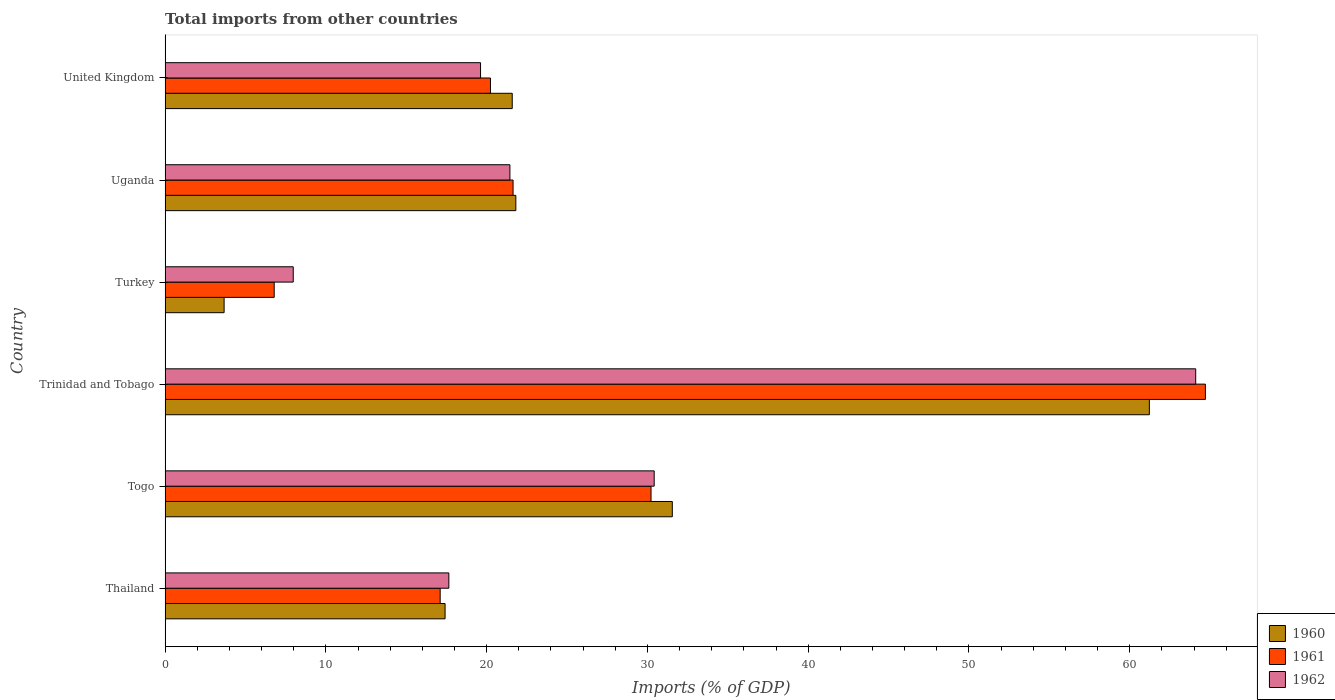How many different coloured bars are there?
Your answer should be compact. 3. How many groups of bars are there?
Ensure brevity in your answer.  6. Are the number of bars per tick equal to the number of legend labels?
Your answer should be compact. Yes. How many bars are there on the 4th tick from the top?
Give a very brief answer. 3. How many bars are there on the 6th tick from the bottom?
Keep it short and to the point. 3. What is the label of the 4th group of bars from the top?
Ensure brevity in your answer.  Trinidad and Tobago. What is the total imports in 1962 in Uganda?
Provide a short and direct response. 21.45. Across all countries, what is the maximum total imports in 1961?
Give a very brief answer. 64.71. Across all countries, what is the minimum total imports in 1962?
Your response must be concise. 7.97. In which country was the total imports in 1962 maximum?
Ensure brevity in your answer.  Trinidad and Tobago. What is the total total imports in 1961 in the graph?
Ensure brevity in your answer.  160.72. What is the difference between the total imports in 1960 in Trinidad and Tobago and that in Uganda?
Provide a succinct answer. 39.41. What is the difference between the total imports in 1960 in Thailand and the total imports in 1961 in Togo?
Your answer should be compact. -12.81. What is the average total imports in 1961 per country?
Your response must be concise. 26.79. What is the difference between the total imports in 1961 and total imports in 1962 in Thailand?
Offer a very short reply. -0.54. In how many countries, is the total imports in 1960 greater than 62 %?
Your answer should be compact. 0. What is the ratio of the total imports in 1961 in Turkey to that in Uganda?
Offer a very short reply. 0.31. Is the difference between the total imports in 1961 in Uganda and United Kingdom greater than the difference between the total imports in 1962 in Uganda and United Kingdom?
Give a very brief answer. No. What is the difference between the highest and the second highest total imports in 1960?
Make the answer very short. 29.67. What is the difference between the highest and the lowest total imports in 1960?
Your answer should be very brief. 57.55. What does the 1st bar from the top in Thailand represents?
Give a very brief answer. 1962. Is it the case that in every country, the sum of the total imports in 1961 and total imports in 1962 is greater than the total imports in 1960?
Your answer should be very brief. Yes. Are all the bars in the graph horizontal?
Keep it short and to the point. Yes. Are the values on the major ticks of X-axis written in scientific E-notation?
Your answer should be compact. No. Does the graph contain any zero values?
Offer a very short reply. No. Where does the legend appear in the graph?
Provide a succinct answer. Bottom right. What is the title of the graph?
Give a very brief answer. Total imports from other countries. Does "1987" appear as one of the legend labels in the graph?
Provide a succinct answer. No. What is the label or title of the X-axis?
Provide a succinct answer. Imports (% of GDP). What is the label or title of the Y-axis?
Your answer should be compact. Country. What is the Imports (% of GDP) in 1960 in Thailand?
Offer a terse response. 17.42. What is the Imports (% of GDP) in 1961 in Thailand?
Give a very brief answer. 17.11. What is the Imports (% of GDP) of 1962 in Thailand?
Your answer should be compact. 17.65. What is the Imports (% of GDP) in 1960 in Togo?
Offer a terse response. 31.55. What is the Imports (% of GDP) in 1961 in Togo?
Make the answer very short. 30.23. What is the Imports (% of GDP) in 1962 in Togo?
Offer a terse response. 30.42. What is the Imports (% of GDP) of 1960 in Trinidad and Tobago?
Your answer should be compact. 61.22. What is the Imports (% of GDP) in 1961 in Trinidad and Tobago?
Ensure brevity in your answer.  64.71. What is the Imports (% of GDP) of 1962 in Trinidad and Tobago?
Your response must be concise. 64.1. What is the Imports (% of GDP) in 1960 in Turkey?
Keep it short and to the point. 3.67. What is the Imports (% of GDP) in 1961 in Turkey?
Your answer should be very brief. 6.79. What is the Imports (% of GDP) of 1962 in Turkey?
Offer a terse response. 7.97. What is the Imports (% of GDP) in 1960 in Uganda?
Offer a terse response. 21.82. What is the Imports (% of GDP) in 1961 in Uganda?
Make the answer very short. 21.64. What is the Imports (% of GDP) of 1962 in Uganda?
Give a very brief answer. 21.45. What is the Imports (% of GDP) in 1960 in United Kingdom?
Your answer should be compact. 21.59. What is the Imports (% of GDP) of 1961 in United Kingdom?
Make the answer very short. 20.24. What is the Imports (% of GDP) in 1962 in United Kingdom?
Provide a short and direct response. 19.62. Across all countries, what is the maximum Imports (% of GDP) of 1960?
Provide a succinct answer. 61.22. Across all countries, what is the maximum Imports (% of GDP) in 1961?
Your response must be concise. 64.71. Across all countries, what is the maximum Imports (% of GDP) in 1962?
Your answer should be compact. 64.1. Across all countries, what is the minimum Imports (% of GDP) of 1960?
Your response must be concise. 3.67. Across all countries, what is the minimum Imports (% of GDP) in 1961?
Give a very brief answer. 6.79. Across all countries, what is the minimum Imports (% of GDP) of 1962?
Keep it short and to the point. 7.97. What is the total Imports (% of GDP) of 1960 in the graph?
Ensure brevity in your answer.  157.27. What is the total Imports (% of GDP) in 1961 in the graph?
Keep it short and to the point. 160.72. What is the total Imports (% of GDP) in 1962 in the graph?
Keep it short and to the point. 161.22. What is the difference between the Imports (% of GDP) in 1960 in Thailand and that in Togo?
Your answer should be compact. -14.13. What is the difference between the Imports (% of GDP) of 1961 in Thailand and that in Togo?
Provide a short and direct response. -13.12. What is the difference between the Imports (% of GDP) of 1962 in Thailand and that in Togo?
Make the answer very short. -12.77. What is the difference between the Imports (% of GDP) of 1960 in Thailand and that in Trinidad and Tobago?
Give a very brief answer. -43.81. What is the difference between the Imports (% of GDP) in 1961 in Thailand and that in Trinidad and Tobago?
Make the answer very short. -47.6. What is the difference between the Imports (% of GDP) in 1962 in Thailand and that in Trinidad and Tobago?
Make the answer very short. -46.46. What is the difference between the Imports (% of GDP) of 1960 in Thailand and that in Turkey?
Your response must be concise. 13.74. What is the difference between the Imports (% of GDP) in 1961 in Thailand and that in Turkey?
Offer a terse response. 10.32. What is the difference between the Imports (% of GDP) of 1962 in Thailand and that in Turkey?
Offer a very short reply. 9.68. What is the difference between the Imports (% of GDP) of 1960 in Thailand and that in Uganda?
Give a very brief answer. -4.4. What is the difference between the Imports (% of GDP) of 1961 in Thailand and that in Uganda?
Your answer should be very brief. -4.53. What is the difference between the Imports (% of GDP) in 1962 in Thailand and that in Uganda?
Your response must be concise. -3.8. What is the difference between the Imports (% of GDP) of 1960 in Thailand and that in United Kingdom?
Keep it short and to the point. -4.18. What is the difference between the Imports (% of GDP) in 1961 in Thailand and that in United Kingdom?
Your answer should be very brief. -3.13. What is the difference between the Imports (% of GDP) in 1962 in Thailand and that in United Kingdom?
Provide a succinct answer. -1.97. What is the difference between the Imports (% of GDP) of 1960 in Togo and that in Trinidad and Tobago?
Give a very brief answer. -29.67. What is the difference between the Imports (% of GDP) of 1961 in Togo and that in Trinidad and Tobago?
Keep it short and to the point. -34.48. What is the difference between the Imports (% of GDP) of 1962 in Togo and that in Trinidad and Tobago?
Make the answer very short. -33.68. What is the difference between the Imports (% of GDP) of 1960 in Togo and that in Turkey?
Your answer should be compact. 27.88. What is the difference between the Imports (% of GDP) in 1961 in Togo and that in Turkey?
Your answer should be very brief. 23.44. What is the difference between the Imports (% of GDP) in 1962 in Togo and that in Turkey?
Your answer should be compact. 22.45. What is the difference between the Imports (% of GDP) of 1960 in Togo and that in Uganda?
Give a very brief answer. 9.73. What is the difference between the Imports (% of GDP) in 1961 in Togo and that in Uganda?
Provide a succinct answer. 8.58. What is the difference between the Imports (% of GDP) in 1962 in Togo and that in Uganda?
Your response must be concise. 8.97. What is the difference between the Imports (% of GDP) in 1960 in Togo and that in United Kingdom?
Your answer should be compact. 9.96. What is the difference between the Imports (% of GDP) in 1961 in Togo and that in United Kingdom?
Your response must be concise. 9.99. What is the difference between the Imports (% of GDP) of 1962 in Togo and that in United Kingdom?
Your answer should be compact. 10.8. What is the difference between the Imports (% of GDP) of 1960 in Trinidad and Tobago and that in Turkey?
Provide a succinct answer. 57.55. What is the difference between the Imports (% of GDP) in 1961 in Trinidad and Tobago and that in Turkey?
Your response must be concise. 57.92. What is the difference between the Imports (% of GDP) of 1962 in Trinidad and Tobago and that in Turkey?
Your response must be concise. 56.13. What is the difference between the Imports (% of GDP) in 1960 in Trinidad and Tobago and that in Uganda?
Provide a succinct answer. 39.41. What is the difference between the Imports (% of GDP) of 1961 in Trinidad and Tobago and that in Uganda?
Your answer should be very brief. 43.06. What is the difference between the Imports (% of GDP) of 1962 in Trinidad and Tobago and that in Uganda?
Your answer should be compact. 42.66. What is the difference between the Imports (% of GDP) in 1960 in Trinidad and Tobago and that in United Kingdom?
Your response must be concise. 39.63. What is the difference between the Imports (% of GDP) of 1961 in Trinidad and Tobago and that in United Kingdom?
Your response must be concise. 44.47. What is the difference between the Imports (% of GDP) in 1962 in Trinidad and Tobago and that in United Kingdom?
Make the answer very short. 44.48. What is the difference between the Imports (% of GDP) in 1960 in Turkey and that in Uganda?
Offer a terse response. -18.15. What is the difference between the Imports (% of GDP) in 1961 in Turkey and that in Uganda?
Make the answer very short. -14.86. What is the difference between the Imports (% of GDP) in 1962 in Turkey and that in Uganda?
Offer a very short reply. -13.48. What is the difference between the Imports (% of GDP) of 1960 in Turkey and that in United Kingdom?
Your answer should be compact. -17.92. What is the difference between the Imports (% of GDP) in 1961 in Turkey and that in United Kingdom?
Give a very brief answer. -13.45. What is the difference between the Imports (% of GDP) in 1962 in Turkey and that in United Kingdom?
Make the answer very short. -11.65. What is the difference between the Imports (% of GDP) of 1960 in Uganda and that in United Kingdom?
Provide a succinct answer. 0.22. What is the difference between the Imports (% of GDP) in 1961 in Uganda and that in United Kingdom?
Ensure brevity in your answer.  1.4. What is the difference between the Imports (% of GDP) in 1962 in Uganda and that in United Kingdom?
Make the answer very short. 1.83. What is the difference between the Imports (% of GDP) in 1960 in Thailand and the Imports (% of GDP) in 1961 in Togo?
Make the answer very short. -12.81. What is the difference between the Imports (% of GDP) of 1960 in Thailand and the Imports (% of GDP) of 1962 in Togo?
Make the answer very short. -13.01. What is the difference between the Imports (% of GDP) in 1961 in Thailand and the Imports (% of GDP) in 1962 in Togo?
Provide a succinct answer. -13.31. What is the difference between the Imports (% of GDP) in 1960 in Thailand and the Imports (% of GDP) in 1961 in Trinidad and Tobago?
Ensure brevity in your answer.  -47.29. What is the difference between the Imports (% of GDP) in 1960 in Thailand and the Imports (% of GDP) in 1962 in Trinidad and Tobago?
Ensure brevity in your answer.  -46.69. What is the difference between the Imports (% of GDP) of 1961 in Thailand and the Imports (% of GDP) of 1962 in Trinidad and Tobago?
Your answer should be compact. -46.99. What is the difference between the Imports (% of GDP) in 1960 in Thailand and the Imports (% of GDP) in 1961 in Turkey?
Ensure brevity in your answer.  10.63. What is the difference between the Imports (% of GDP) in 1960 in Thailand and the Imports (% of GDP) in 1962 in Turkey?
Ensure brevity in your answer.  9.45. What is the difference between the Imports (% of GDP) in 1961 in Thailand and the Imports (% of GDP) in 1962 in Turkey?
Ensure brevity in your answer.  9.14. What is the difference between the Imports (% of GDP) in 1960 in Thailand and the Imports (% of GDP) in 1961 in Uganda?
Your answer should be compact. -4.23. What is the difference between the Imports (% of GDP) in 1960 in Thailand and the Imports (% of GDP) in 1962 in Uganda?
Keep it short and to the point. -4.03. What is the difference between the Imports (% of GDP) in 1961 in Thailand and the Imports (% of GDP) in 1962 in Uganda?
Ensure brevity in your answer.  -4.34. What is the difference between the Imports (% of GDP) in 1960 in Thailand and the Imports (% of GDP) in 1961 in United Kingdom?
Provide a short and direct response. -2.82. What is the difference between the Imports (% of GDP) in 1960 in Thailand and the Imports (% of GDP) in 1962 in United Kingdom?
Your answer should be very brief. -2.21. What is the difference between the Imports (% of GDP) of 1961 in Thailand and the Imports (% of GDP) of 1962 in United Kingdom?
Your response must be concise. -2.51. What is the difference between the Imports (% of GDP) of 1960 in Togo and the Imports (% of GDP) of 1961 in Trinidad and Tobago?
Provide a short and direct response. -33.16. What is the difference between the Imports (% of GDP) in 1960 in Togo and the Imports (% of GDP) in 1962 in Trinidad and Tobago?
Offer a very short reply. -32.56. What is the difference between the Imports (% of GDP) in 1961 in Togo and the Imports (% of GDP) in 1962 in Trinidad and Tobago?
Provide a succinct answer. -33.88. What is the difference between the Imports (% of GDP) of 1960 in Togo and the Imports (% of GDP) of 1961 in Turkey?
Ensure brevity in your answer.  24.76. What is the difference between the Imports (% of GDP) of 1960 in Togo and the Imports (% of GDP) of 1962 in Turkey?
Offer a very short reply. 23.58. What is the difference between the Imports (% of GDP) of 1961 in Togo and the Imports (% of GDP) of 1962 in Turkey?
Provide a succinct answer. 22.26. What is the difference between the Imports (% of GDP) of 1960 in Togo and the Imports (% of GDP) of 1961 in Uganda?
Provide a short and direct response. 9.91. What is the difference between the Imports (% of GDP) in 1960 in Togo and the Imports (% of GDP) in 1962 in Uganda?
Your response must be concise. 10.1. What is the difference between the Imports (% of GDP) of 1961 in Togo and the Imports (% of GDP) of 1962 in Uganda?
Provide a short and direct response. 8.78. What is the difference between the Imports (% of GDP) of 1960 in Togo and the Imports (% of GDP) of 1961 in United Kingdom?
Your answer should be compact. 11.31. What is the difference between the Imports (% of GDP) of 1960 in Togo and the Imports (% of GDP) of 1962 in United Kingdom?
Give a very brief answer. 11.93. What is the difference between the Imports (% of GDP) of 1961 in Togo and the Imports (% of GDP) of 1962 in United Kingdom?
Ensure brevity in your answer.  10.6. What is the difference between the Imports (% of GDP) in 1960 in Trinidad and Tobago and the Imports (% of GDP) in 1961 in Turkey?
Provide a short and direct response. 54.44. What is the difference between the Imports (% of GDP) of 1960 in Trinidad and Tobago and the Imports (% of GDP) of 1962 in Turkey?
Keep it short and to the point. 53.25. What is the difference between the Imports (% of GDP) in 1961 in Trinidad and Tobago and the Imports (% of GDP) in 1962 in Turkey?
Provide a short and direct response. 56.74. What is the difference between the Imports (% of GDP) of 1960 in Trinidad and Tobago and the Imports (% of GDP) of 1961 in Uganda?
Ensure brevity in your answer.  39.58. What is the difference between the Imports (% of GDP) in 1960 in Trinidad and Tobago and the Imports (% of GDP) in 1962 in Uganda?
Ensure brevity in your answer.  39.77. What is the difference between the Imports (% of GDP) in 1961 in Trinidad and Tobago and the Imports (% of GDP) in 1962 in Uganda?
Your response must be concise. 43.26. What is the difference between the Imports (% of GDP) of 1960 in Trinidad and Tobago and the Imports (% of GDP) of 1961 in United Kingdom?
Your response must be concise. 40.98. What is the difference between the Imports (% of GDP) of 1960 in Trinidad and Tobago and the Imports (% of GDP) of 1962 in United Kingdom?
Provide a succinct answer. 41.6. What is the difference between the Imports (% of GDP) in 1961 in Trinidad and Tobago and the Imports (% of GDP) in 1962 in United Kingdom?
Give a very brief answer. 45.09. What is the difference between the Imports (% of GDP) of 1960 in Turkey and the Imports (% of GDP) of 1961 in Uganda?
Offer a terse response. -17.97. What is the difference between the Imports (% of GDP) of 1960 in Turkey and the Imports (% of GDP) of 1962 in Uganda?
Make the answer very short. -17.78. What is the difference between the Imports (% of GDP) of 1961 in Turkey and the Imports (% of GDP) of 1962 in Uganda?
Offer a terse response. -14.66. What is the difference between the Imports (% of GDP) in 1960 in Turkey and the Imports (% of GDP) in 1961 in United Kingdom?
Offer a terse response. -16.57. What is the difference between the Imports (% of GDP) of 1960 in Turkey and the Imports (% of GDP) of 1962 in United Kingdom?
Make the answer very short. -15.95. What is the difference between the Imports (% of GDP) of 1961 in Turkey and the Imports (% of GDP) of 1962 in United Kingdom?
Keep it short and to the point. -12.83. What is the difference between the Imports (% of GDP) in 1960 in Uganda and the Imports (% of GDP) in 1961 in United Kingdom?
Your answer should be very brief. 1.58. What is the difference between the Imports (% of GDP) in 1960 in Uganda and the Imports (% of GDP) in 1962 in United Kingdom?
Make the answer very short. 2.2. What is the difference between the Imports (% of GDP) of 1961 in Uganda and the Imports (% of GDP) of 1962 in United Kingdom?
Ensure brevity in your answer.  2.02. What is the average Imports (% of GDP) of 1960 per country?
Keep it short and to the point. 26.21. What is the average Imports (% of GDP) of 1961 per country?
Keep it short and to the point. 26.79. What is the average Imports (% of GDP) of 1962 per country?
Your response must be concise. 26.87. What is the difference between the Imports (% of GDP) of 1960 and Imports (% of GDP) of 1961 in Thailand?
Keep it short and to the point. 0.31. What is the difference between the Imports (% of GDP) of 1960 and Imports (% of GDP) of 1962 in Thailand?
Keep it short and to the point. -0.23. What is the difference between the Imports (% of GDP) in 1961 and Imports (% of GDP) in 1962 in Thailand?
Offer a terse response. -0.54. What is the difference between the Imports (% of GDP) of 1960 and Imports (% of GDP) of 1961 in Togo?
Offer a terse response. 1.32. What is the difference between the Imports (% of GDP) in 1960 and Imports (% of GDP) in 1962 in Togo?
Keep it short and to the point. 1.13. What is the difference between the Imports (% of GDP) of 1961 and Imports (% of GDP) of 1962 in Togo?
Offer a very short reply. -0.2. What is the difference between the Imports (% of GDP) in 1960 and Imports (% of GDP) in 1961 in Trinidad and Tobago?
Give a very brief answer. -3.49. What is the difference between the Imports (% of GDP) in 1960 and Imports (% of GDP) in 1962 in Trinidad and Tobago?
Make the answer very short. -2.88. What is the difference between the Imports (% of GDP) in 1961 and Imports (% of GDP) in 1962 in Trinidad and Tobago?
Ensure brevity in your answer.  0.6. What is the difference between the Imports (% of GDP) of 1960 and Imports (% of GDP) of 1961 in Turkey?
Your answer should be compact. -3.12. What is the difference between the Imports (% of GDP) of 1960 and Imports (% of GDP) of 1962 in Turkey?
Provide a short and direct response. -4.3. What is the difference between the Imports (% of GDP) in 1961 and Imports (% of GDP) in 1962 in Turkey?
Give a very brief answer. -1.18. What is the difference between the Imports (% of GDP) in 1960 and Imports (% of GDP) in 1961 in Uganda?
Ensure brevity in your answer.  0.17. What is the difference between the Imports (% of GDP) in 1960 and Imports (% of GDP) in 1962 in Uganda?
Your answer should be very brief. 0.37. What is the difference between the Imports (% of GDP) in 1961 and Imports (% of GDP) in 1962 in Uganda?
Make the answer very short. 0.2. What is the difference between the Imports (% of GDP) of 1960 and Imports (% of GDP) of 1961 in United Kingdom?
Ensure brevity in your answer.  1.35. What is the difference between the Imports (% of GDP) of 1960 and Imports (% of GDP) of 1962 in United Kingdom?
Ensure brevity in your answer.  1.97. What is the difference between the Imports (% of GDP) in 1961 and Imports (% of GDP) in 1962 in United Kingdom?
Ensure brevity in your answer.  0.62. What is the ratio of the Imports (% of GDP) of 1960 in Thailand to that in Togo?
Ensure brevity in your answer.  0.55. What is the ratio of the Imports (% of GDP) in 1961 in Thailand to that in Togo?
Ensure brevity in your answer.  0.57. What is the ratio of the Imports (% of GDP) of 1962 in Thailand to that in Togo?
Offer a terse response. 0.58. What is the ratio of the Imports (% of GDP) of 1960 in Thailand to that in Trinidad and Tobago?
Give a very brief answer. 0.28. What is the ratio of the Imports (% of GDP) in 1961 in Thailand to that in Trinidad and Tobago?
Keep it short and to the point. 0.26. What is the ratio of the Imports (% of GDP) in 1962 in Thailand to that in Trinidad and Tobago?
Provide a short and direct response. 0.28. What is the ratio of the Imports (% of GDP) of 1960 in Thailand to that in Turkey?
Your answer should be very brief. 4.74. What is the ratio of the Imports (% of GDP) of 1961 in Thailand to that in Turkey?
Ensure brevity in your answer.  2.52. What is the ratio of the Imports (% of GDP) in 1962 in Thailand to that in Turkey?
Make the answer very short. 2.21. What is the ratio of the Imports (% of GDP) in 1960 in Thailand to that in Uganda?
Offer a terse response. 0.8. What is the ratio of the Imports (% of GDP) of 1961 in Thailand to that in Uganda?
Offer a terse response. 0.79. What is the ratio of the Imports (% of GDP) in 1962 in Thailand to that in Uganda?
Keep it short and to the point. 0.82. What is the ratio of the Imports (% of GDP) in 1960 in Thailand to that in United Kingdom?
Offer a terse response. 0.81. What is the ratio of the Imports (% of GDP) in 1961 in Thailand to that in United Kingdom?
Your answer should be compact. 0.85. What is the ratio of the Imports (% of GDP) in 1962 in Thailand to that in United Kingdom?
Keep it short and to the point. 0.9. What is the ratio of the Imports (% of GDP) of 1960 in Togo to that in Trinidad and Tobago?
Your response must be concise. 0.52. What is the ratio of the Imports (% of GDP) in 1961 in Togo to that in Trinidad and Tobago?
Offer a terse response. 0.47. What is the ratio of the Imports (% of GDP) of 1962 in Togo to that in Trinidad and Tobago?
Offer a terse response. 0.47. What is the ratio of the Imports (% of GDP) of 1960 in Togo to that in Turkey?
Ensure brevity in your answer.  8.59. What is the ratio of the Imports (% of GDP) of 1961 in Togo to that in Turkey?
Keep it short and to the point. 4.45. What is the ratio of the Imports (% of GDP) of 1962 in Togo to that in Turkey?
Your response must be concise. 3.82. What is the ratio of the Imports (% of GDP) in 1960 in Togo to that in Uganda?
Your answer should be very brief. 1.45. What is the ratio of the Imports (% of GDP) of 1961 in Togo to that in Uganda?
Your answer should be very brief. 1.4. What is the ratio of the Imports (% of GDP) of 1962 in Togo to that in Uganda?
Your answer should be very brief. 1.42. What is the ratio of the Imports (% of GDP) of 1960 in Togo to that in United Kingdom?
Make the answer very short. 1.46. What is the ratio of the Imports (% of GDP) of 1961 in Togo to that in United Kingdom?
Ensure brevity in your answer.  1.49. What is the ratio of the Imports (% of GDP) of 1962 in Togo to that in United Kingdom?
Offer a very short reply. 1.55. What is the ratio of the Imports (% of GDP) in 1960 in Trinidad and Tobago to that in Turkey?
Ensure brevity in your answer.  16.68. What is the ratio of the Imports (% of GDP) of 1961 in Trinidad and Tobago to that in Turkey?
Keep it short and to the point. 9.53. What is the ratio of the Imports (% of GDP) in 1962 in Trinidad and Tobago to that in Turkey?
Offer a terse response. 8.04. What is the ratio of the Imports (% of GDP) in 1960 in Trinidad and Tobago to that in Uganda?
Provide a succinct answer. 2.81. What is the ratio of the Imports (% of GDP) of 1961 in Trinidad and Tobago to that in Uganda?
Keep it short and to the point. 2.99. What is the ratio of the Imports (% of GDP) in 1962 in Trinidad and Tobago to that in Uganda?
Your answer should be very brief. 2.99. What is the ratio of the Imports (% of GDP) of 1960 in Trinidad and Tobago to that in United Kingdom?
Give a very brief answer. 2.84. What is the ratio of the Imports (% of GDP) of 1961 in Trinidad and Tobago to that in United Kingdom?
Make the answer very short. 3.2. What is the ratio of the Imports (% of GDP) in 1962 in Trinidad and Tobago to that in United Kingdom?
Ensure brevity in your answer.  3.27. What is the ratio of the Imports (% of GDP) in 1960 in Turkey to that in Uganda?
Offer a very short reply. 0.17. What is the ratio of the Imports (% of GDP) in 1961 in Turkey to that in Uganda?
Offer a terse response. 0.31. What is the ratio of the Imports (% of GDP) in 1962 in Turkey to that in Uganda?
Keep it short and to the point. 0.37. What is the ratio of the Imports (% of GDP) of 1960 in Turkey to that in United Kingdom?
Make the answer very short. 0.17. What is the ratio of the Imports (% of GDP) of 1961 in Turkey to that in United Kingdom?
Keep it short and to the point. 0.34. What is the ratio of the Imports (% of GDP) in 1962 in Turkey to that in United Kingdom?
Offer a very short reply. 0.41. What is the ratio of the Imports (% of GDP) of 1960 in Uganda to that in United Kingdom?
Provide a succinct answer. 1.01. What is the ratio of the Imports (% of GDP) in 1961 in Uganda to that in United Kingdom?
Provide a succinct answer. 1.07. What is the ratio of the Imports (% of GDP) of 1962 in Uganda to that in United Kingdom?
Provide a succinct answer. 1.09. What is the difference between the highest and the second highest Imports (% of GDP) in 1960?
Offer a terse response. 29.67. What is the difference between the highest and the second highest Imports (% of GDP) in 1961?
Provide a succinct answer. 34.48. What is the difference between the highest and the second highest Imports (% of GDP) in 1962?
Your answer should be very brief. 33.68. What is the difference between the highest and the lowest Imports (% of GDP) in 1960?
Provide a short and direct response. 57.55. What is the difference between the highest and the lowest Imports (% of GDP) in 1961?
Keep it short and to the point. 57.92. What is the difference between the highest and the lowest Imports (% of GDP) of 1962?
Keep it short and to the point. 56.13. 